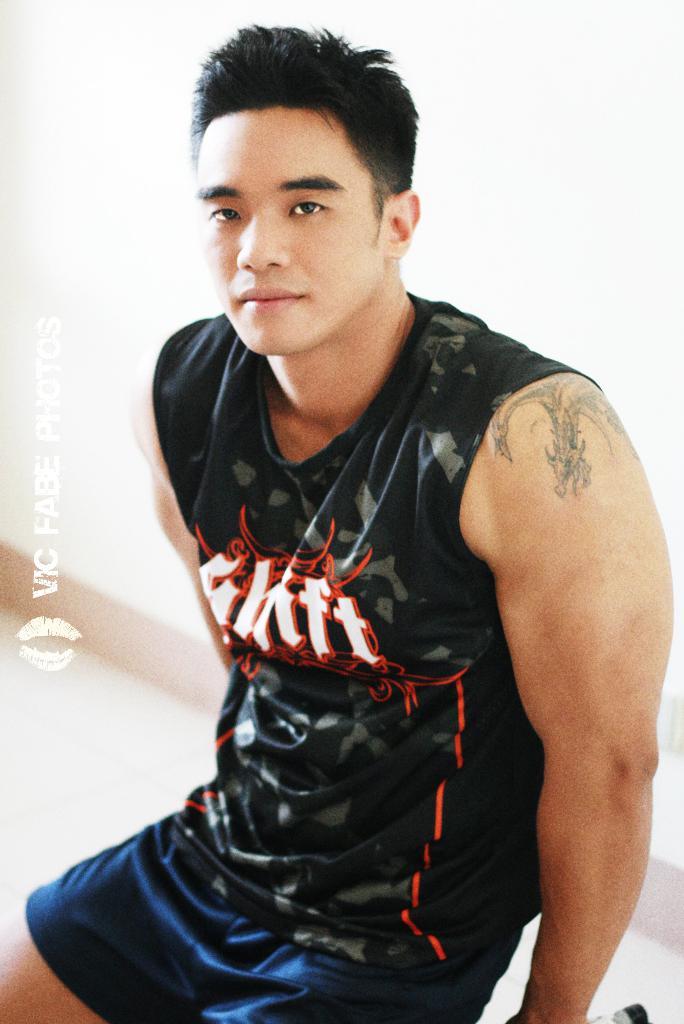What is mentioned on this person's shirt, in the middle?
Keep it short and to the point. Shift. 